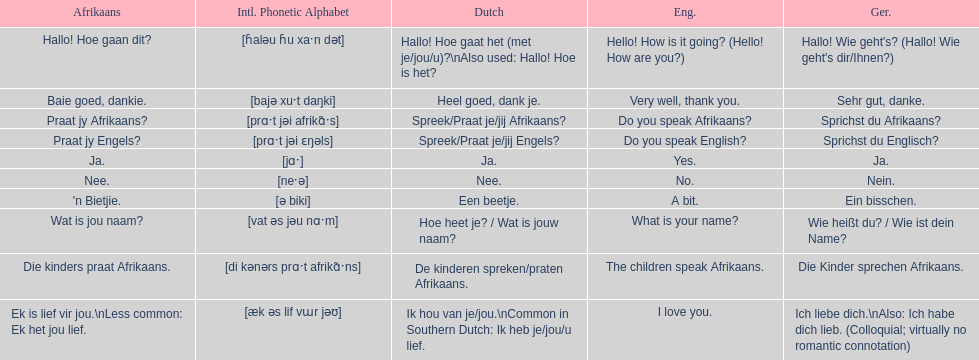How do you say hello! how is it going? in afrikaans? Hallo! Hoe gaan dit?. How do you say very well, thank you in afrikaans? Baie goed, dankie. How would you say do you speak afrikaans? in afrikaans? Praat jy Afrikaans?. 